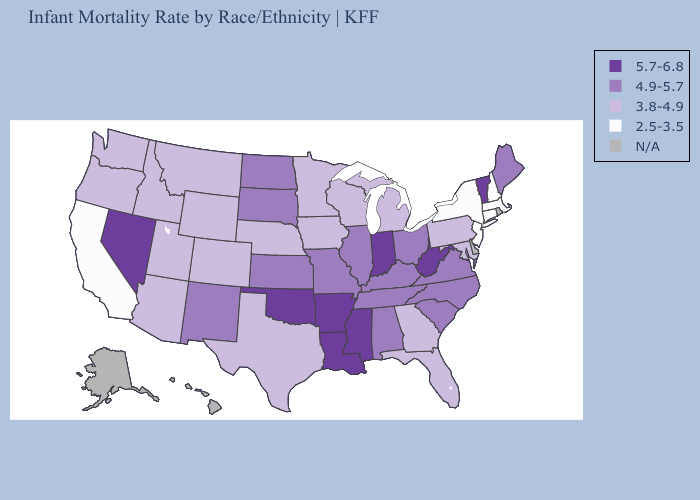What is the value of Georgia?
Be succinct. 3.8-4.9. What is the lowest value in the USA?
Write a very short answer. 2.5-3.5. Which states have the lowest value in the MidWest?
Concise answer only. Iowa, Michigan, Minnesota, Nebraska, Wisconsin. What is the lowest value in the USA?
Write a very short answer. 2.5-3.5. Does Massachusetts have the lowest value in the USA?
Be succinct. Yes. What is the lowest value in states that border Missouri?
Write a very short answer. 3.8-4.9. Name the states that have a value in the range 4.9-5.7?
Short answer required. Alabama, Illinois, Kansas, Kentucky, Maine, Missouri, New Mexico, North Carolina, North Dakota, Ohio, South Carolina, South Dakota, Tennessee, Virginia. What is the highest value in the USA?
Give a very brief answer. 5.7-6.8. Name the states that have a value in the range 4.9-5.7?
Answer briefly. Alabama, Illinois, Kansas, Kentucky, Maine, Missouri, New Mexico, North Carolina, North Dakota, Ohio, South Carolina, South Dakota, Tennessee, Virginia. What is the value of West Virginia?
Answer briefly. 5.7-6.8. Among the states that border Tennessee , which have the highest value?
Answer briefly. Arkansas, Mississippi. Name the states that have a value in the range 2.5-3.5?
Keep it brief. California, Connecticut, Massachusetts, New Hampshire, New Jersey, New York. Name the states that have a value in the range 4.9-5.7?
Write a very short answer. Alabama, Illinois, Kansas, Kentucky, Maine, Missouri, New Mexico, North Carolina, North Dakota, Ohio, South Carolina, South Dakota, Tennessee, Virginia. Does Virginia have the highest value in the USA?
Answer briefly. No. How many symbols are there in the legend?
Answer briefly. 5. 